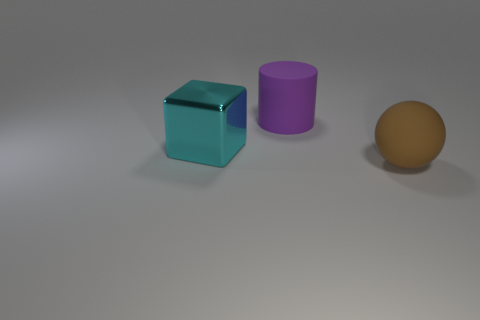What is the color of the object that is behind the big brown object and right of the cyan metal block?
Provide a short and direct response. Purple. Is the cyan shiny object the same shape as the big purple object?
Your answer should be compact. No. What is the shape of the thing to the left of the rubber object behind the cyan object?
Your answer should be compact. Cube. There is a purple thing; is it the same shape as the large thing right of the big purple matte thing?
Provide a short and direct response. No. The rubber thing that is the same size as the purple rubber cylinder is what color?
Your answer should be very brief. Brown. Is the number of large cyan blocks that are on the right side of the big purple cylinder less than the number of rubber objects to the left of the large sphere?
Keep it short and to the point. Yes. What shape is the matte object that is in front of the matte thing left of the large rubber object to the right of the large purple cylinder?
Your answer should be compact. Sphere. There is a rubber object behind the block; does it have the same color as the thing that is right of the matte cylinder?
Offer a very short reply. No. What number of matte objects are large yellow things or brown objects?
Keep it short and to the point. 1. There is a big matte object that is in front of the large matte thing that is left of the large brown rubber object on the right side of the large purple cylinder; what is its color?
Keep it short and to the point. Brown. 